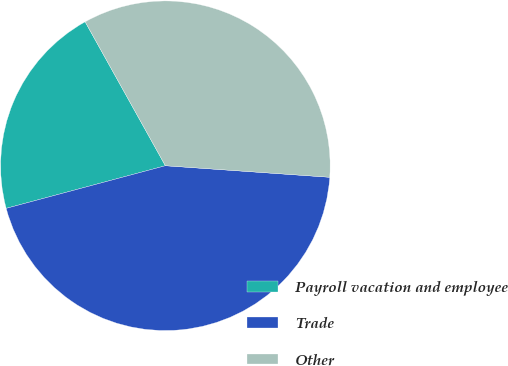Convert chart to OTSL. <chart><loc_0><loc_0><loc_500><loc_500><pie_chart><fcel>Payroll vacation and employee<fcel>Trade<fcel>Other<nl><fcel>21.07%<fcel>44.72%<fcel>34.21%<nl></chart> 